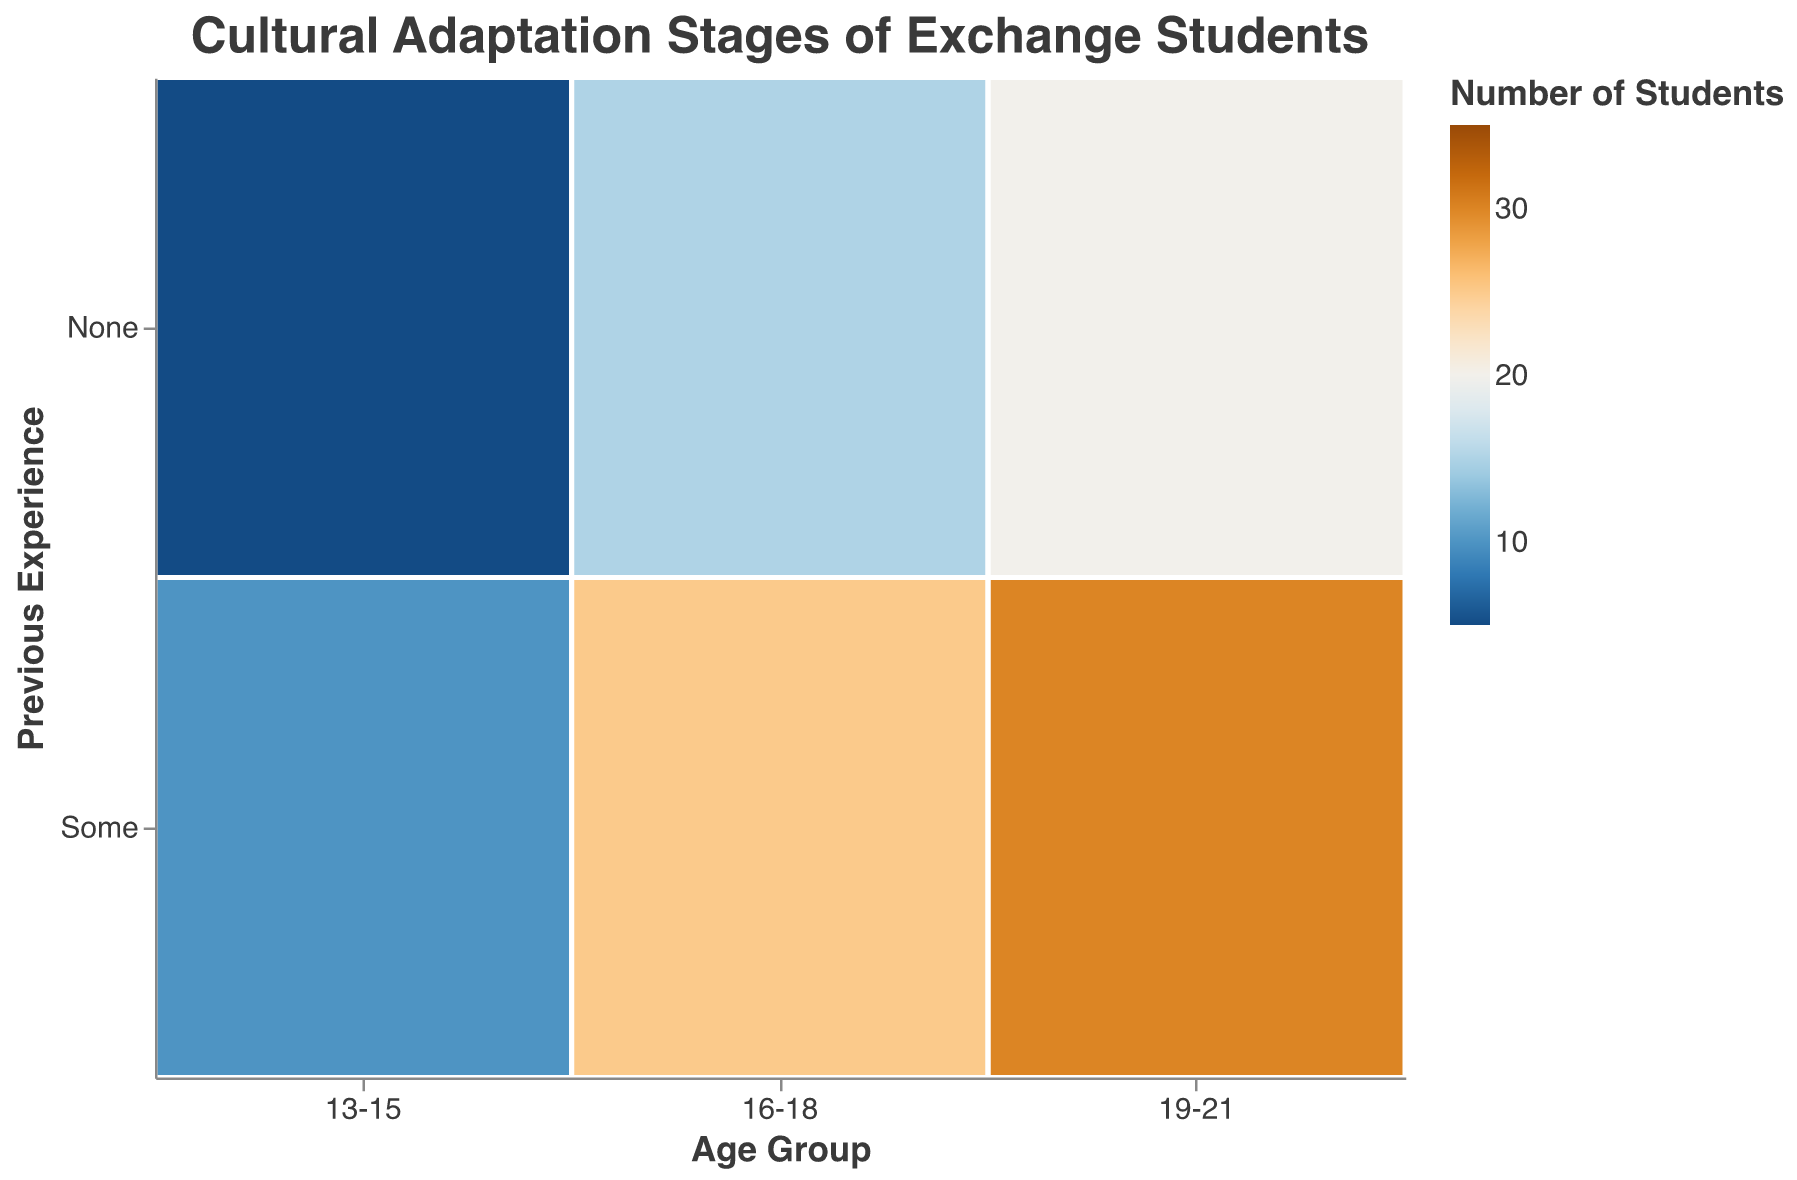What is the title of the figure? The title of the figure is displayed at the top and represents the main focus of the visualization. It reads "Cultural Adaptation Stages of Exchange Students"
Answer: Cultural Adaptation Stages of Exchange Students How is previous international experience depicted in the plot? Previous international experience is shown on the y-axis and is categorized into "None" and "Some"
Answer: "None" and "Some" Which adaptation stage has the highest number of students in the 19-21 age group with no previous international experience? By observing the colors and sizes of the areas, we can see that the "Culture Shock" stage has the highest number of students in the 19-21 age group with no previous international experience.
Answer: Culture Shock What is the total number of students in the 16-18 age group who have some previous international experience? Add the numbers for each adaptation stage in the 16-18 age group with some previous international experience: Honeymoon (15) + Culture Shock (20) + Adjustment (30) + Adaptation (25) = 90
Answer: 90 Compare the number of students in the "Adjustment" stage between the 13-15 and 19-21 age groups with some previous experience. Which group has more students? The number of students in the "Adjustment" stage for the 13-15 age group with some previous experience is 20, while the 19-21 age group with some previous experience has 35 students. Therefore, the 19-21 age group has more students.
Answer: 19-21 age group Which color scheme is used to represent the number of students? The figure uses a color scheme that ranges from blue to orange to represent the number of students. This can be observed in the color gradient on the plot
Answer: Blue to orange For the 13-15 age group with no previous international experience, what is the difference in the number of students between the "Honeymoon" and "Adjustment" stages? Identify the numbers for the "Honeymoon" and "Adjustment" stages in the 13-15 age group with no previous experience: Honeymoon (15) - Adjustment (10) = 5
Answer: 5 Within the 16-18 age group, which adaptation stage has the fewest students with some previous international experience? By observing the colors and sizes of the areas, the "Honeymoon" stage has the fewest number of students with some previous international experience in the 16-18 age group, with 15 students
Answer: Honeymoon What is the average number of students in the "Adaptation" stage across all age groups with some previous international experience? Add the numbers for the "Adaptation" stage in each age group with some previous experience: 13-15 (10) + 16-18 (25) + 19-21 (30) = 65. Divide by the number of groups (3): 65/3 ≈ 21.67
Answer: 21.67 Which age group has the highest number of students in the "Honeymoon" stage with no previous international experience? The 19-21 age group has the highest number of students in the "Honeymoon" stage with no previous international experience, with 25 students
Answer: 19-21 